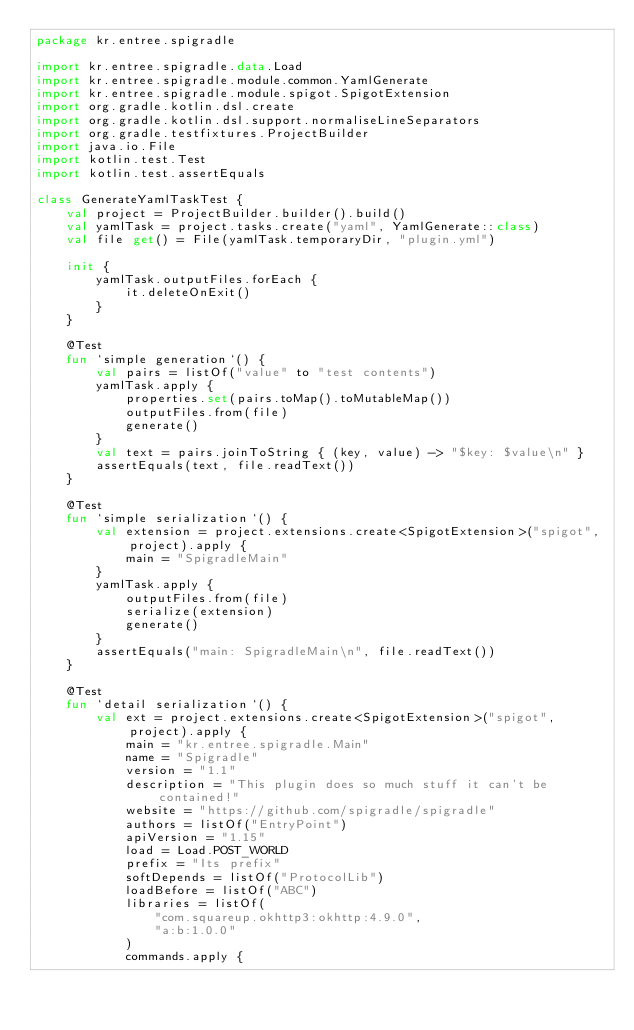Convert code to text. <code><loc_0><loc_0><loc_500><loc_500><_Kotlin_>package kr.entree.spigradle

import kr.entree.spigradle.data.Load
import kr.entree.spigradle.module.common.YamlGenerate
import kr.entree.spigradle.module.spigot.SpigotExtension
import org.gradle.kotlin.dsl.create
import org.gradle.kotlin.dsl.support.normaliseLineSeparators
import org.gradle.testfixtures.ProjectBuilder
import java.io.File
import kotlin.test.Test
import kotlin.test.assertEquals

class GenerateYamlTaskTest {
    val project = ProjectBuilder.builder().build()
    val yamlTask = project.tasks.create("yaml", YamlGenerate::class)
    val file get() = File(yamlTask.temporaryDir, "plugin.yml")

    init {
        yamlTask.outputFiles.forEach {
            it.deleteOnExit()
        }
    }

    @Test
    fun `simple generation`() {
        val pairs = listOf("value" to "test contents")
        yamlTask.apply {
            properties.set(pairs.toMap().toMutableMap())
            outputFiles.from(file)
            generate()
        }
        val text = pairs.joinToString { (key, value) -> "$key: $value\n" }
        assertEquals(text, file.readText())
    }

    @Test
    fun `simple serialization`() {
        val extension = project.extensions.create<SpigotExtension>("spigot", project).apply {
            main = "SpigradleMain"
        }
        yamlTask.apply {
            outputFiles.from(file)
            serialize(extension)
            generate()
        }
        assertEquals("main: SpigradleMain\n", file.readText())
    }

    @Test
    fun `detail serialization`() {
        val ext = project.extensions.create<SpigotExtension>("spigot", project).apply {
            main = "kr.entree.spigradle.Main"
            name = "Spigradle"
            version = "1.1"
            description = "This plugin does so much stuff it can't be contained!"
            website = "https://github.com/spigradle/spigradle"
            authors = listOf("EntryPoint")
            apiVersion = "1.15"
            load = Load.POST_WORLD
            prefix = "Its prefix"
            softDepends = listOf("ProtocolLib")
            loadBefore = listOf("ABC")
            libraries = listOf(
                "com.squareup.okhttp3:okhttp:4.9.0",
                "a:b:1.0.0"
            )
            commands.apply {</code> 